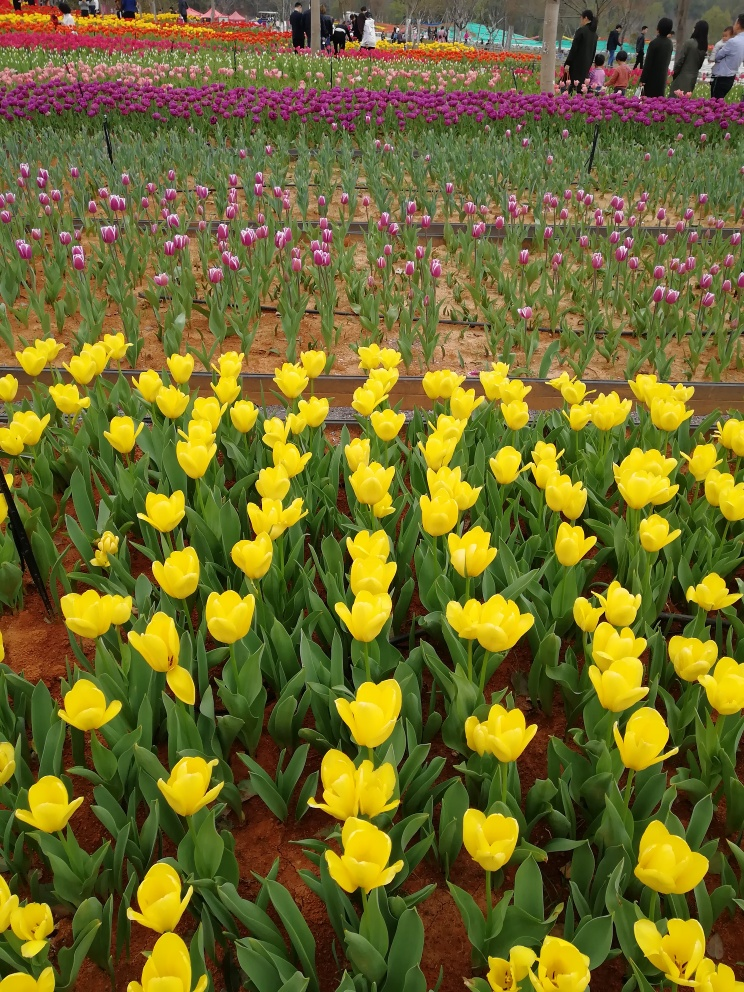Describe the quality of the image, and the provide a final evaluation
 This photo captures a tulip garden. The focus is very sharp, and the colors are rich and vibrant. There are no visible noise or artifacts, so the quality of this photo is excellent, and it is very beautiful. 